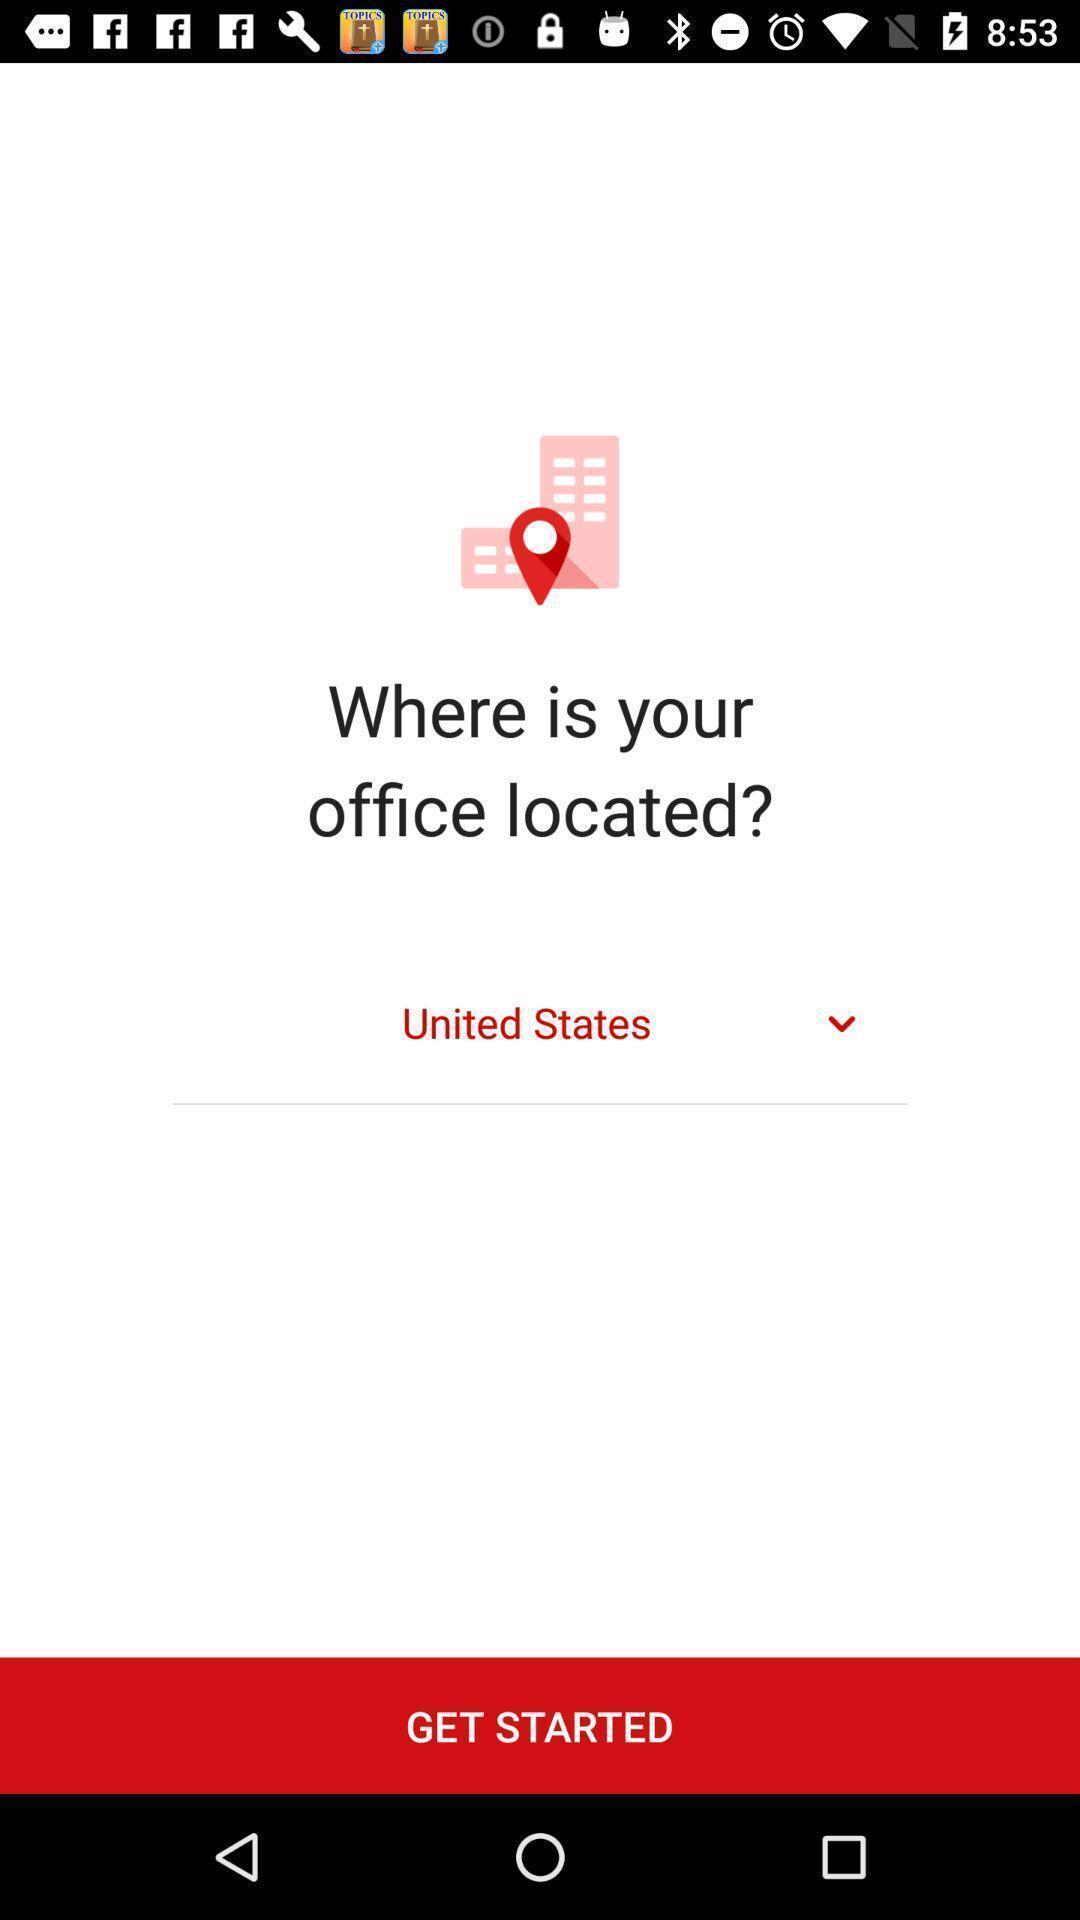Tell me about the visual elements in this screen capture. Start page. 